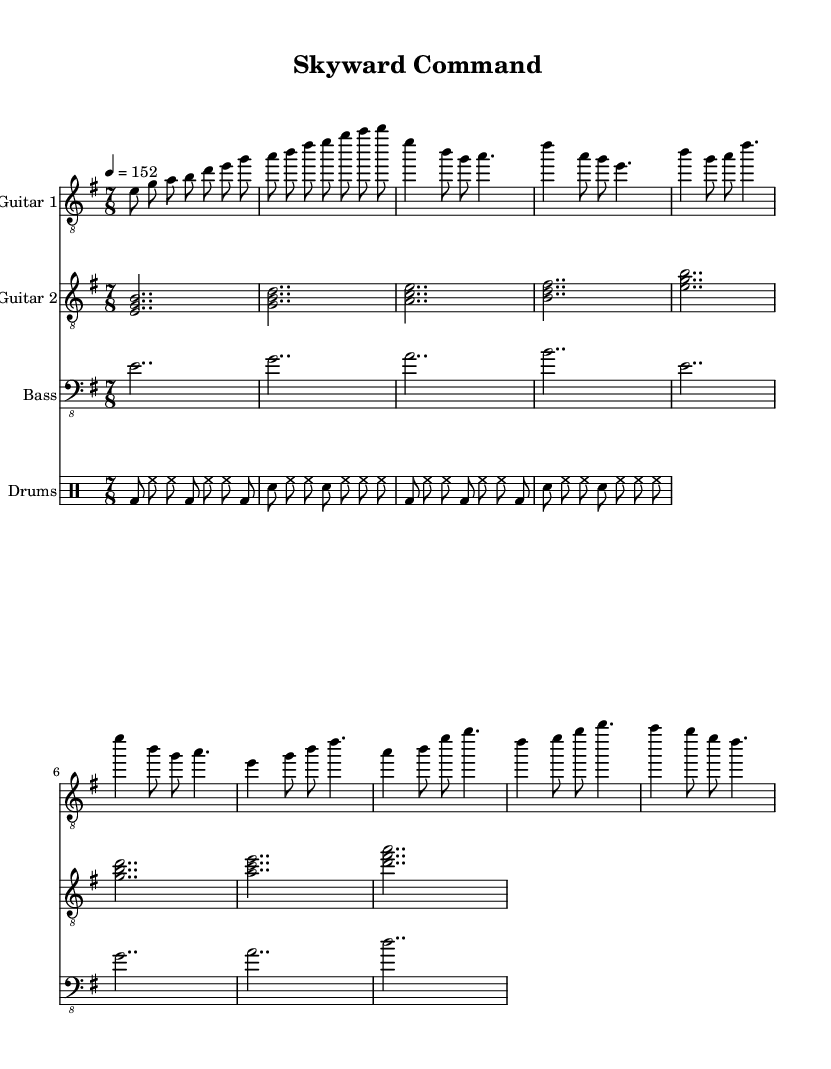What is the key signature of this music? The key signature is E minor, which has one sharp (F#). It can be identified by the key signature positioned at the beginning of the staff lines.
Answer: E minor What is the time signature of this music? The time signature is 7/8, indicated by the two numbers at the beginning of the staff, where the top number represents the number of beats in a measure and the bottom number indicates the note value that receives one beat.
Answer: 7/8 What is the tempo marking of this piece? The tempo marking is 4 = 152, indicating that there are four beats in a measure and the tempo is set to 152 beats per minute. This can be found in the header information written near the top of the sheet music.
Answer: 152 Which section of the music features a change from the corresponding phrases in the intro and verse? The section that typically contrasts with the verses, often with a more powerful and anthemic sound, is the chorus. This can be derived from observing the structure and dynamics in the piece.
Answer: Chorus How many measures are in the intro? The intro comprises eight measures, which can be counted directly from the notation in guitar one and guitar two parts that together constitute the intro section before the verses begin.
Answer: 8 What is the function of the bass line in this piece? The bass line serves to provide harmonic support and rhythm, complementing the guitar parts. It outlines the chord progressions and adds depth to the overall sound. This can be deduced by analyzing how the bass aligns with the chords played by the guitars throughout the piece.
Answer: Harmonic support What melodic interval is prominently featured in the chorus? The melodic interval prominently featured in the chorus is a perfect fourth, which is identifiable between certain notes in the guitar melodies that distinctly emphasize this relationship during the chorus.
Answer: Perfect fourth 